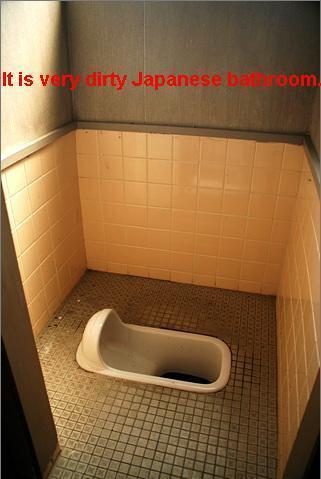How many walls are there?
Give a very brief answer. 3. 